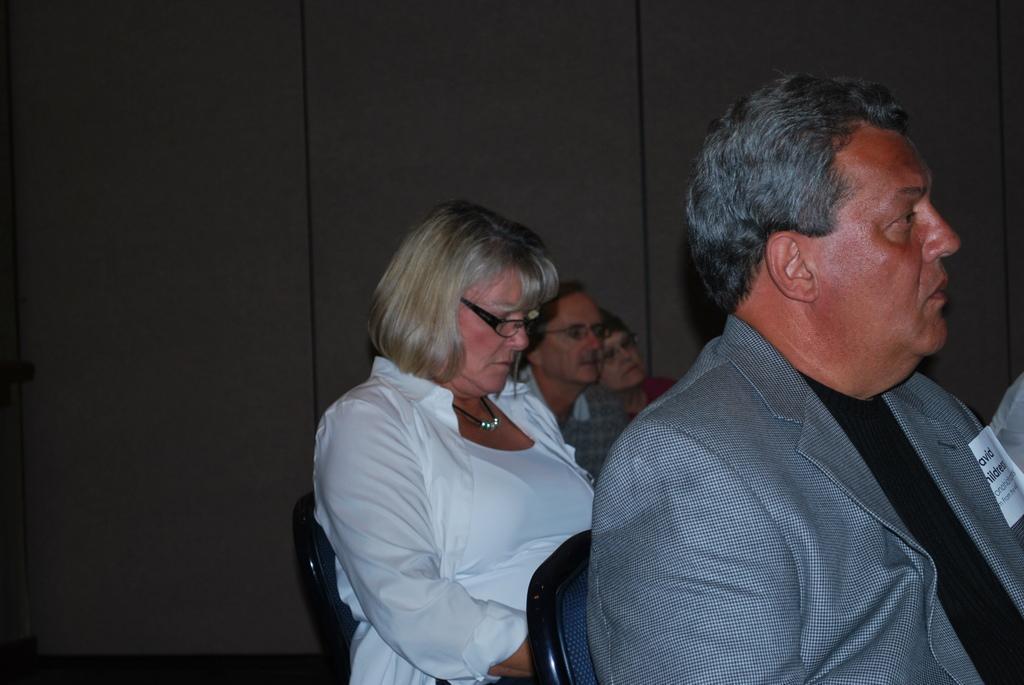Can you describe this image briefly? There are few people sitting on chairs. And a lady wearing a white dress, chain and specs is sitting in the back. And in the background there is a wall. 